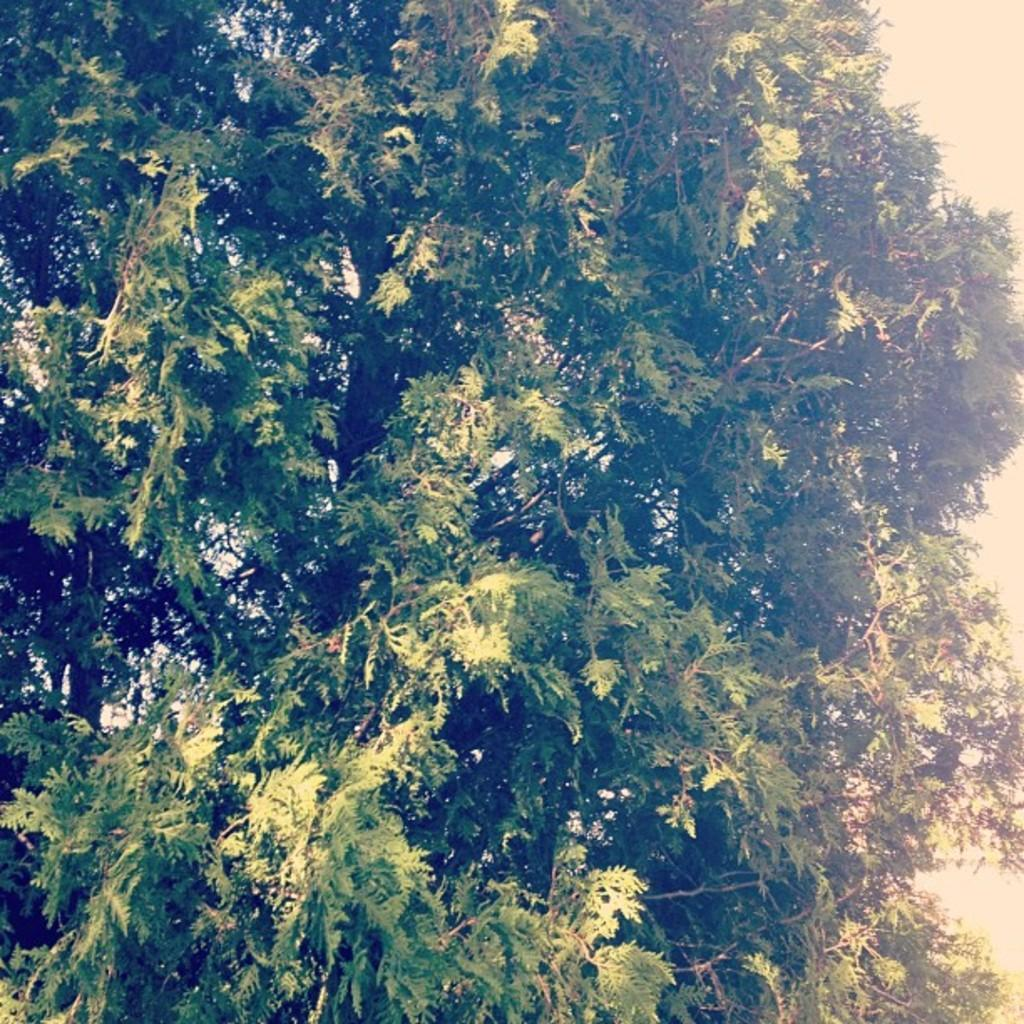What is the main feature of the image? There is a huge tree in the image. Can you describe the tree in more detail? The tree has many branches. What type of tray is being used for the class during the holiday in the image? There is no tray, class, or holiday depicted in the image; it only features a huge tree with many branches. 